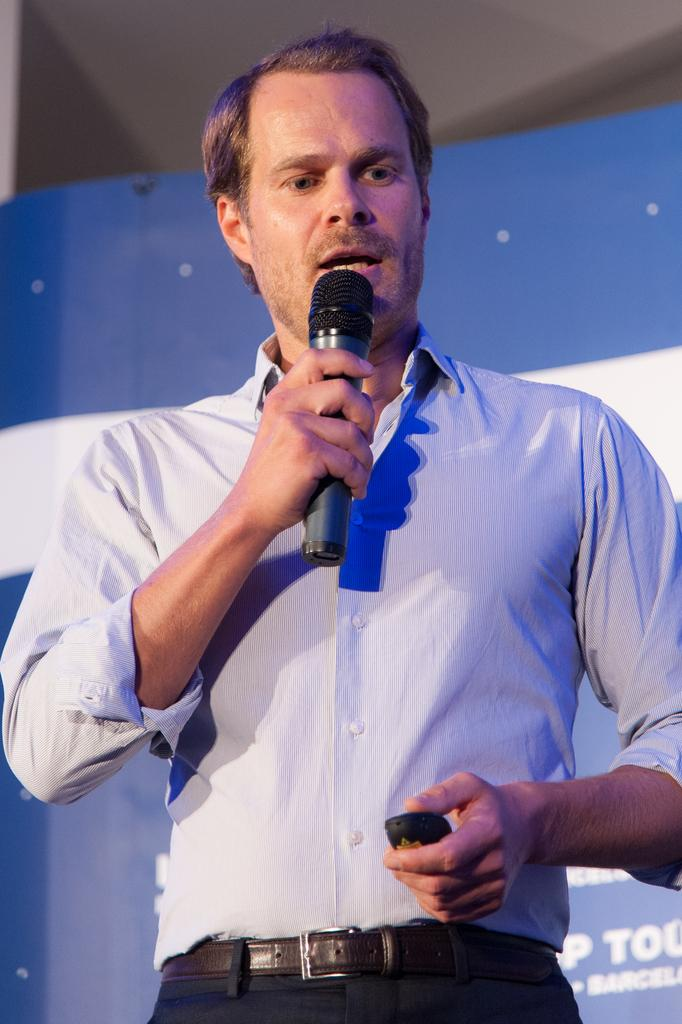Who is the main subject in the image? There is a man in the image. What is the man holding in the image? The man is holding a microphone. What is the man doing in the image? The man is talking. What can be seen in the background of the image? There is a banner in the background of the image. What colors are present on the banner? The banner has blue and white colors. What holiday is being celebrated in the image? There is no indication of a holiday being celebrated in the image. 